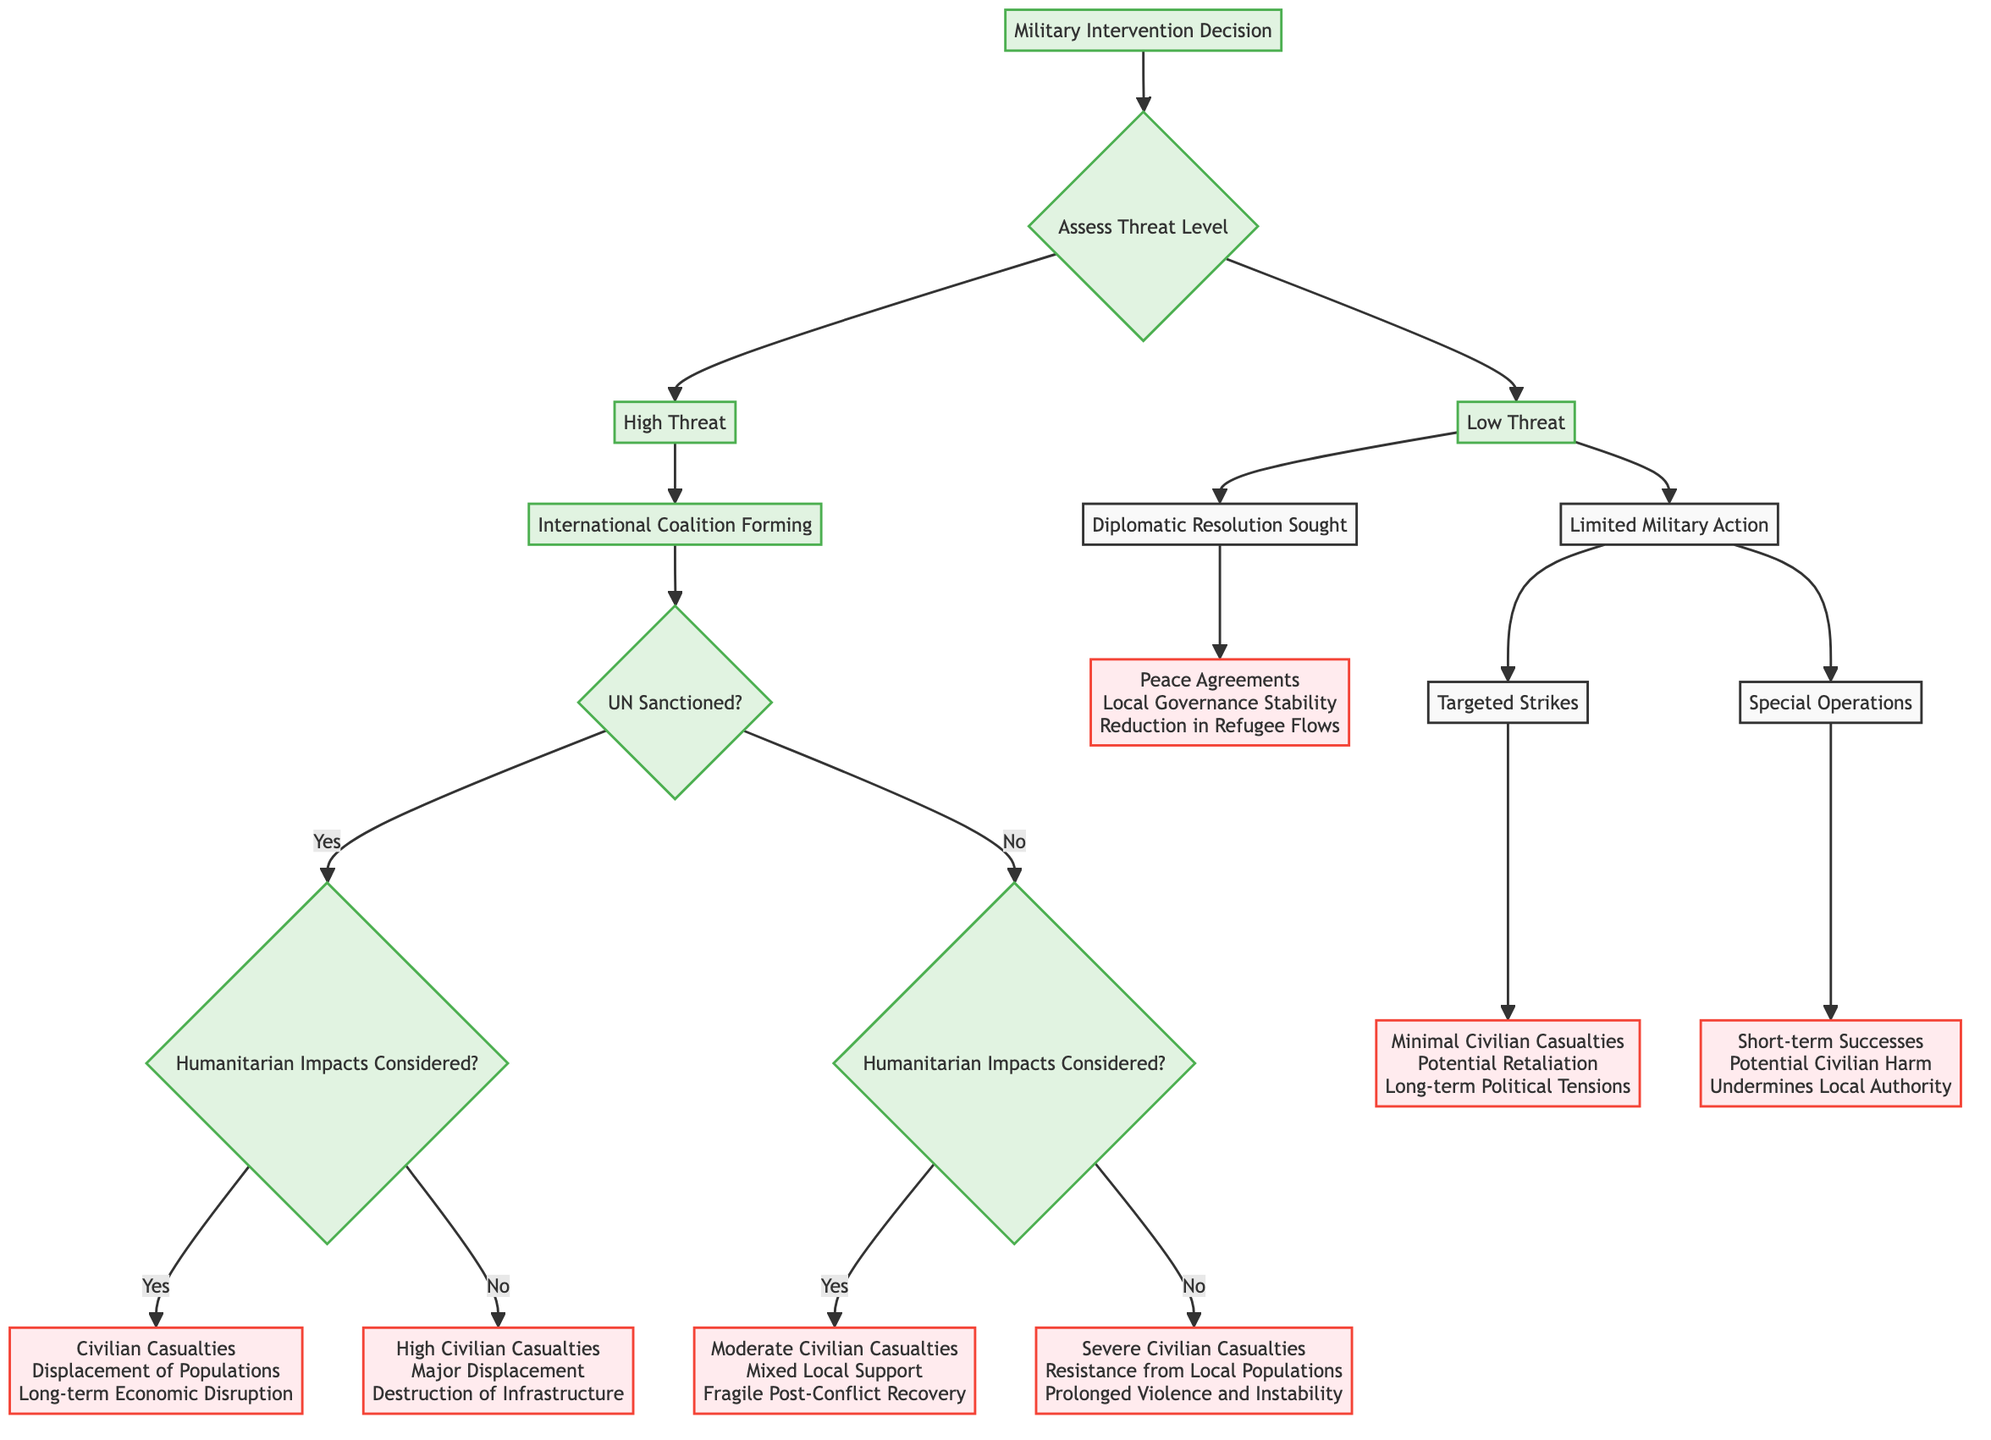What is the root node of the decision tree? The root node represents the starting point of the decision-making process regarding military intervention, which is "Military Intervention Decision."
Answer: Military Intervention Decision How many children does the "Assess Threat Level" node have? The "Assess Threat Level" node has two children: "High Threat" and "Low Threat."
Answer: 2 What consequences are listed under "Humanitarian Impacts Not Considered" for a UN sanctioned intervention? The consequences listed are "High Civilian Casualties," "Major Displacement," and "Destruction of Infrastructure."
Answer: High Civilian Casualties, Major Displacement, Destruction of Infrastructure Which node results in "Peace Agreements"? The outcome "Peace Agreements" is associated with the node "Diplomatic Resolution Sought" under the "Low Threat" category.
Answer: Peace Agreements If the threat level is low and limited military action is taken, what are two potential outcomes? The outcomes are "Minimal Civilian Casualties" and "Potential Retaliation," which are consequences of the "Targeted Strikes" node under "Limited Military Action."
Answer: Minimal Civilian Casualties, Potential Retaliation What happens if an intervention is classified as "High Threat" with no humanitarian impacts considered? The consequences will include "Severe Civilian Casualties," "Resistance from Local Populations," and "Prolonged Violence and Instability."
Answer: Severe Civilian Casualties, Resistance from Local Populations, Prolonged Violence and Instability In the case of a "Limited Military Action" categorized as "Special Operations," what are the consequences? The consequences listed for this action include "Short-term Successes," "Potential Civilian Harm," and "Undermines Local Authority."
Answer: Short-term Successes, Potential Civilian Harm, Undermines Local Authority What does the presence of an international coalition forming under "High Threat" signify? An international coalition forming under "High Threat" indicates a collective effort to intervene, leading to decisions on sanctions and considerations of humanitarian impacts that will shape the intervention.
Answer: International Coalition Forming What is the consequence of a "Diplomatic Resolution Sought" in terms of local governance? The result is "Local Governance Stability," indicating that diplomatic efforts contribute positively to the stability of governance in the region.
Answer: Local Governance Stability 